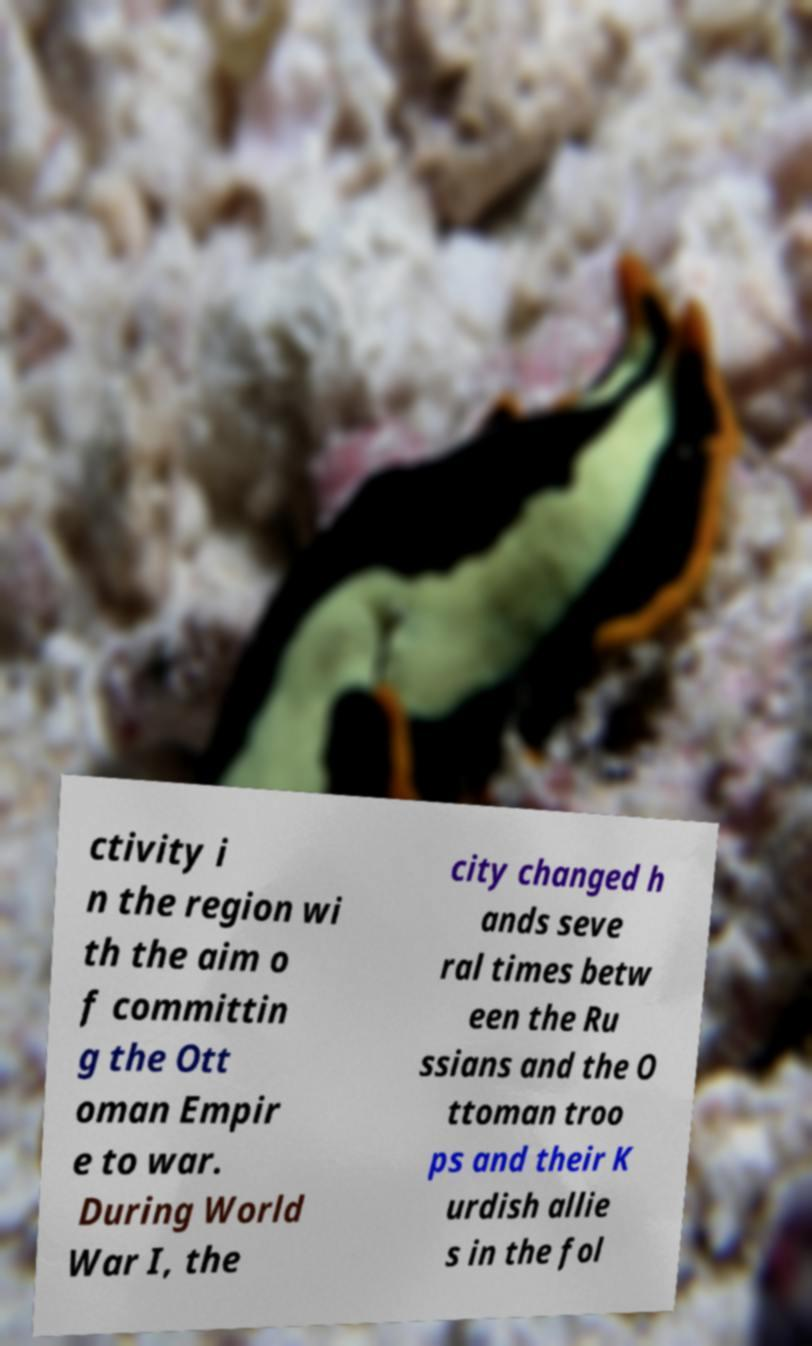There's text embedded in this image that I need extracted. Can you transcribe it verbatim? ctivity i n the region wi th the aim o f committin g the Ott oman Empir e to war. During World War I, the city changed h ands seve ral times betw een the Ru ssians and the O ttoman troo ps and their K urdish allie s in the fol 